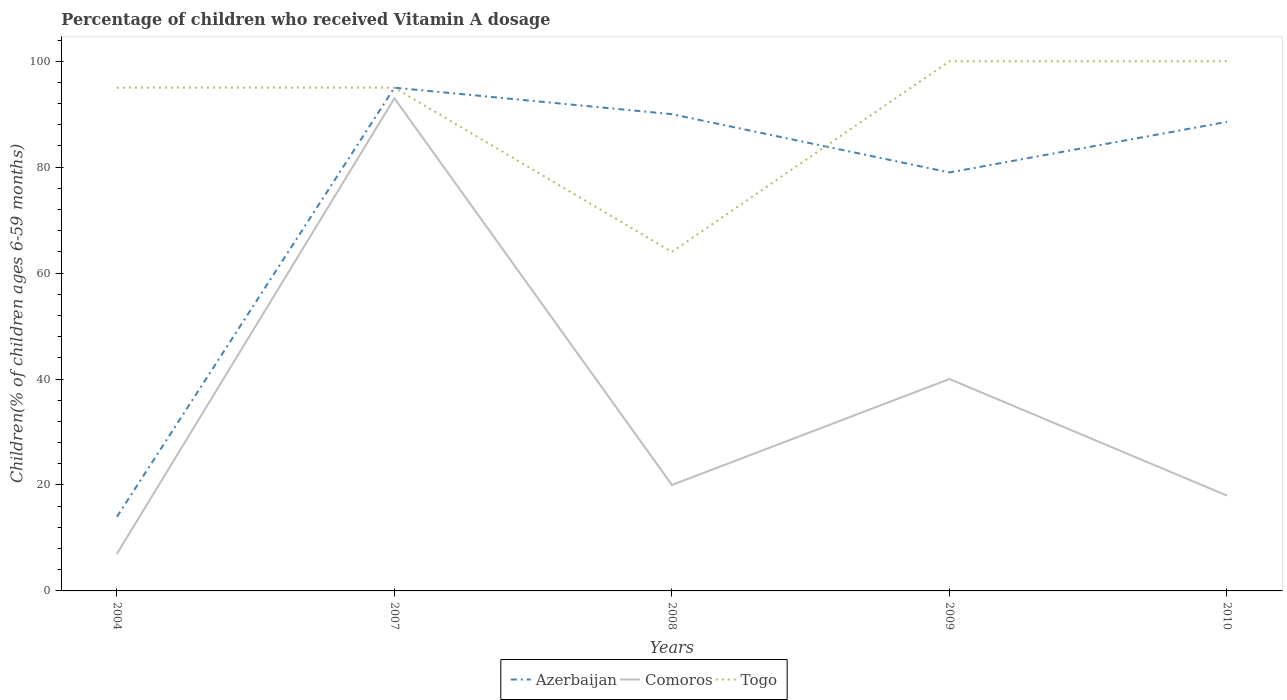How many different coloured lines are there?
Your answer should be very brief. 3. Across all years, what is the maximum percentage of children who received Vitamin A dosage in Togo?
Your answer should be compact. 64. Is the percentage of children who received Vitamin A dosage in Togo strictly greater than the percentage of children who received Vitamin A dosage in Comoros over the years?
Your answer should be very brief. No. How many lines are there?
Give a very brief answer. 3. What is the difference between two consecutive major ticks on the Y-axis?
Your answer should be very brief. 20. Are the values on the major ticks of Y-axis written in scientific E-notation?
Ensure brevity in your answer.  No. Does the graph contain any zero values?
Your response must be concise. No. Where does the legend appear in the graph?
Offer a terse response. Bottom center. What is the title of the graph?
Offer a terse response. Percentage of children who received Vitamin A dosage. Does "Turkey" appear as one of the legend labels in the graph?
Provide a succinct answer. No. What is the label or title of the X-axis?
Your answer should be very brief. Years. What is the label or title of the Y-axis?
Keep it short and to the point. Children(% of children ages 6-59 months). What is the Children(% of children ages 6-59 months) of Azerbaijan in 2004?
Your response must be concise. 14. What is the Children(% of children ages 6-59 months) of Comoros in 2004?
Offer a terse response. 7. What is the Children(% of children ages 6-59 months) of Togo in 2004?
Keep it short and to the point. 95. What is the Children(% of children ages 6-59 months) in Azerbaijan in 2007?
Provide a short and direct response. 95. What is the Children(% of children ages 6-59 months) of Comoros in 2007?
Provide a short and direct response. 93. What is the Children(% of children ages 6-59 months) in Comoros in 2008?
Your answer should be very brief. 20. What is the Children(% of children ages 6-59 months) of Azerbaijan in 2009?
Ensure brevity in your answer.  79. What is the Children(% of children ages 6-59 months) of Comoros in 2009?
Provide a succinct answer. 40. What is the Children(% of children ages 6-59 months) of Azerbaijan in 2010?
Your response must be concise. 88.55. What is the Children(% of children ages 6-59 months) of Togo in 2010?
Make the answer very short. 100. Across all years, what is the maximum Children(% of children ages 6-59 months) of Azerbaijan?
Provide a succinct answer. 95. Across all years, what is the maximum Children(% of children ages 6-59 months) of Comoros?
Make the answer very short. 93. Across all years, what is the maximum Children(% of children ages 6-59 months) of Togo?
Provide a short and direct response. 100. Across all years, what is the minimum Children(% of children ages 6-59 months) in Azerbaijan?
Keep it short and to the point. 14. Across all years, what is the minimum Children(% of children ages 6-59 months) in Togo?
Your answer should be very brief. 64. What is the total Children(% of children ages 6-59 months) of Azerbaijan in the graph?
Your answer should be very brief. 366.55. What is the total Children(% of children ages 6-59 months) in Comoros in the graph?
Give a very brief answer. 178. What is the total Children(% of children ages 6-59 months) in Togo in the graph?
Your response must be concise. 454. What is the difference between the Children(% of children ages 6-59 months) of Azerbaijan in 2004 and that in 2007?
Your answer should be very brief. -81. What is the difference between the Children(% of children ages 6-59 months) of Comoros in 2004 and that in 2007?
Your answer should be compact. -86. What is the difference between the Children(% of children ages 6-59 months) in Azerbaijan in 2004 and that in 2008?
Ensure brevity in your answer.  -76. What is the difference between the Children(% of children ages 6-59 months) in Comoros in 2004 and that in 2008?
Keep it short and to the point. -13. What is the difference between the Children(% of children ages 6-59 months) of Azerbaijan in 2004 and that in 2009?
Make the answer very short. -65. What is the difference between the Children(% of children ages 6-59 months) of Comoros in 2004 and that in 2009?
Provide a succinct answer. -33. What is the difference between the Children(% of children ages 6-59 months) in Azerbaijan in 2004 and that in 2010?
Ensure brevity in your answer.  -74.55. What is the difference between the Children(% of children ages 6-59 months) in Togo in 2004 and that in 2010?
Offer a terse response. -5. What is the difference between the Children(% of children ages 6-59 months) of Comoros in 2007 and that in 2008?
Your answer should be very brief. 73. What is the difference between the Children(% of children ages 6-59 months) in Azerbaijan in 2007 and that in 2009?
Give a very brief answer. 16. What is the difference between the Children(% of children ages 6-59 months) in Comoros in 2007 and that in 2009?
Your answer should be compact. 53. What is the difference between the Children(% of children ages 6-59 months) in Togo in 2007 and that in 2009?
Your answer should be very brief. -5. What is the difference between the Children(% of children ages 6-59 months) of Azerbaijan in 2007 and that in 2010?
Your response must be concise. 6.45. What is the difference between the Children(% of children ages 6-59 months) in Comoros in 2007 and that in 2010?
Provide a short and direct response. 75. What is the difference between the Children(% of children ages 6-59 months) of Togo in 2007 and that in 2010?
Your answer should be very brief. -5. What is the difference between the Children(% of children ages 6-59 months) of Togo in 2008 and that in 2009?
Provide a short and direct response. -36. What is the difference between the Children(% of children ages 6-59 months) in Azerbaijan in 2008 and that in 2010?
Keep it short and to the point. 1.45. What is the difference between the Children(% of children ages 6-59 months) of Comoros in 2008 and that in 2010?
Offer a terse response. 2. What is the difference between the Children(% of children ages 6-59 months) in Togo in 2008 and that in 2010?
Offer a terse response. -36. What is the difference between the Children(% of children ages 6-59 months) of Azerbaijan in 2009 and that in 2010?
Your answer should be compact. -9.55. What is the difference between the Children(% of children ages 6-59 months) in Comoros in 2009 and that in 2010?
Your response must be concise. 22. What is the difference between the Children(% of children ages 6-59 months) of Azerbaijan in 2004 and the Children(% of children ages 6-59 months) of Comoros in 2007?
Give a very brief answer. -79. What is the difference between the Children(% of children ages 6-59 months) in Azerbaijan in 2004 and the Children(% of children ages 6-59 months) in Togo in 2007?
Keep it short and to the point. -81. What is the difference between the Children(% of children ages 6-59 months) of Comoros in 2004 and the Children(% of children ages 6-59 months) of Togo in 2007?
Provide a succinct answer. -88. What is the difference between the Children(% of children ages 6-59 months) of Azerbaijan in 2004 and the Children(% of children ages 6-59 months) of Togo in 2008?
Your answer should be very brief. -50. What is the difference between the Children(% of children ages 6-59 months) in Comoros in 2004 and the Children(% of children ages 6-59 months) in Togo in 2008?
Offer a very short reply. -57. What is the difference between the Children(% of children ages 6-59 months) in Azerbaijan in 2004 and the Children(% of children ages 6-59 months) in Comoros in 2009?
Your answer should be compact. -26. What is the difference between the Children(% of children ages 6-59 months) of Azerbaijan in 2004 and the Children(% of children ages 6-59 months) of Togo in 2009?
Your response must be concise. -86. What is the difference between the Children(% of children ages 6-59 months) of Comoros in 2004 and the Children(% of children ages 6-59 months) of Togo in 2009?
Your answer should be compact. -93. What is the difference between the Children(% of children ages 6-59 months) of Azerbaijan in 2004 and the Children(% of children ages 6-59 months) of Togo in 2010?
Keep it short and to the point. -86. What is the difference between the Children(% of children ages 6-59 months) in Comoros in 2004 and the Children(% of children ages 6-59 months) in Togo in 2010?
Keep it short and to the point. -93. What is the difference between the Children(% of children ages 6-59 months) in Azerbaijan in 2007 and the Children(% of children ages 6-59 months) in Togo in 2008?
Your answer should be compact. 31. What is the difference between the Children(% of children ages 6-59 months) of Azerbaijan in 2007 and the Children(% of children ages 6-59 months) of Togo in 2009?
Offer a terse response. -5. What is the difference between the Children(% of children ages 6-59 months) of Comoros in 2007 and the Children(% of children ages 6-59 months) of Togo in 2009?
Your response must be concise. -7. What is the difference between the Children(% of children ages 6-59 months) in Azerbaijan in 2007 and the Children(% of children ages 6-59 months) in Togo in 2010?
Provide a short and direct response. -5. What is the difference between the Children(% of children ages 6-59 months) in Azerbaijan in 2008 and the Children(% of children ages 6-59 months) in Comoros in 2009?
Provide a succinct answer. 50. What is the difference between the Children(% of children ages 6-59 months) in Comoros in 2008 and the Children(% of children ages 6-59 months) in Togo in 2009?
Keep it short and to the point. -80. What is the difference between the Children(% of children ages 6-59 months) of Azerbaijan in 2008 and the Children(% of children ages 6-59 months) of Togo in 2010?
Your answer should be compact. -10. What is the difference between the Children(% of children ages 6-59 months) of Comoros in 2008 and the Children(% of children ages 6-59 months) of Togo in 2010?
Ensure brevity in your answer.  -80. What is the difference between the Children(% of children ages 6-59 months) in Azerbaijan in 2009 and the Children(% of children ages 6-59 months) in Comoros in 2010?
Your answer should be very brief. 61. What is the difference between the Children(% of children ages 6-59 months) in Comoros in 2009 and the Children(% of children ages 6-59 months) in Togo in 2010?
Make the answer very short. -60. What is the average Children(% of children ages 6-59 months) in Azerbaijan per year?
Your answer should be compact. 73.31. What is the average Children(% of children ages 6-59 months) in Comoros per year?
Provide a succinct answer. 35.6. What is the average Children(% of children ages 6-59 months) of Togo per year?
Your answer should be very brief. 90.8. In the year 2004, what is the difference between the Children(% of children ages 6-59 months) in Azerbaijan and Children(% of children ages 6-59 months) in Comoros?
Provide a succinct answer. 7. In the year 2004, what is the difference between the Children(% of children ages 6-59 months) of Azerbaijan and Children(% of children ages 6-59 months) of Togo?
Provide a short and direct response. -81. In the year 2004, what is the difference between the Children(% of children ages 6-59 months) of Comoros and Children(% of children ages 6-59 months) of Togo?
Provide a short and direct response. -88. In the year 2007, what is the difference between the Children(% of children ages 6-59 months) of Azerbaijan and Children(% of children ages 6-59 months) of Togo?
Your answer should be very brief. 0. In the year 2008, what is the difference between the Children(% of children ages 6-59 months) of Azerbaijan and Children(% of children ages 6-59 months) of Comoros?
Offer a terse response. 70. In the year 2008, what is the difference between the Children(% of children ages 6-59 months) of Azerbaijan and Children(% of children ages 6-59 months) of Togo?
Give a very brief answer. 26. In the year 2008, what is the difference between the Children(% of children ages 6-59 months) in Comoros and Children(% of children ages 6-59 months) in Togo?
Your answer should be compact. -44. In the year 2009, what is the difference between the Children(% of children ages 6-59 months) in Azerbaijan and Children(% of children ages 6-59 months) in Togo?
Keep it short and to the point. -21. In the year 2009, what is the difference between the Children(% of children ages 6-59 months) of Comoros and Children(% of children ages 6-59 months) of Togo?
Give a very brief answer. -60. In the year 2010, what is the difference between the Children(% of children ages 6-59 months) in Azerbaijan and Children(% of children ages 6-59 months) in Comoros?
Offer a terse response. 70.55. In the year 2010, what is the difference between the Children(% of children ages 6-59 months) in Azerbaijan and Children(% of children ages 6-59 months) in Togo?
Provide a short and direct response. -11.45. In the year 2010, what is the difference between the Children(% of children ages 6-59 months) of Comoros and Children(% of children ages 6-59 months) of Togo?
Give a very brief answer. -82. What is the ratio of the Children(% of children ages 6-59 months) of Azerbaijan in 2004 to that in 2007?
Offer a terse response. 0.15. What is the ratio of the Children(% of children ages 6-59 months) in Comoros in 2004 to that in 2007?
Make the answer very short. 0.08. What is the ratio of the Children(% of children ages 6-59 months) in Azerbaijan in 2004 to that in 2008?
Make the answer very short. 0.16. What is the ratio of the Children(% of children ages 6-59 months) in Comoros in 2004 to that in 2008?
Offer a very short reply. 0.35. What is the ratio of the Children(% of children ages 6-59 months) of Togo in 2004 to that in 2008?
Your response must be concise. 1.48. What is the ratio of the Children(% of children ages 6-59 months) in Azerbaijan in 2004 to that in 2009?
Provide a short and direct response. 0.18. What is the ratio of the Children(% of children ages 6-59 months) of Comoros in 2004 to that in 2009?
Offer a very short reply. 0.17. What is the ratio of the Children(% of children ages 6-59 months) in Togo in 2004 to that in 2009?
Your answer should be very brief. 0.95. What is the ratio of the Children(% of children ages 6-59 months) of Azerbaijan in 2004 to that in 2010?
Make the answer very short. 0.16. What is the ratio of the Children(% of children ages 6-59 months) of Comoros in 2004 to that in 2010?
Make the answer very short. 0.39. What is the ratio of the Children(% of children ages 6-59 months) of Togo in 2004 to that in 2010?
Your response must be concise. 0.95. What is the ratio of the Children(% of children ages 6-59 months) in Azerbaijan in 2007 to that in 2008?
Ensure brevity in your answer.  1.06. What is the ratio of the Children(% of children ages 6-59 months) in Comoros in 2007 to that in 2008?
Offer a terse response. 4.65. What is the ratio of the Children(% of children ages 6-59 months) of Togo in 2007 to that in 2008?
Offer a terse response. 1.48. What is the ratio of the Children(% of children ages 6-59 months) in Azerbaijan in 2007 to that in 2009?
Offer a terse response. 1.2. What is the ratio of the Children(% of children ages 6-59 months) in Comoros in 2007 to that in 2009?
Offer a very short reply. 2.33. What is the ratio of the Children(% of children ages 6-59 months) of Togo in 2007 to that in 2009?
Ensure brevity in your answer.  0.95. What is the ratio of the Children(% of children ages 6-59 months) of Azerbaijan in 2007 to that in 2010?
Keep it short and to the point. 1.07. What is the ratio of the Children(% of children ages 6-59 months) of Comoros in 2007 to that in 2010?
Offer a very short reply. 5.17. What is the ratio of the Children(% of children ages 6-59 months) in Azerbaijan in 2008 to that in 2009?
Your answer should be compact. 1.14. What is the ratio of the Children(% of children ages 6-59 months) of Togo in 2008 to that in 2009?
Your answer should be compact. 0.64. What is the ratio of the Children(% of children ages 6-59 months) in Azerbaijan in 2008 to that in 2010?
Ensure brevity in your answer.  1.02. What is the ratio of the Children(% of children ages 6-59 months) of Togo in 2008 to that in 2010?
Provide a short and direct response. 0.64. What is the ratio of the Children(% of children ages 6-59 months) in Azerbaijan in 2009 to that in 2010?
Make the answer very short. 0.89. What is the ratio of the Children(% of children ages 6-59 months) of Comoros in 2009 to that in 2010?
Your response must be concise. 2.22. What is the ratio of the Children(% of children ages 6-59 months) in Togo in 2009 to that in 2010?
Offer a terse response. 1. What is the difference between the highest and the second highest Children(% of children ages 6-59 months) in Togo?
Keep it short and to the point. 0. What is the difference between the highest and the lowest Children(% of children ages 6-59 months) in Togo?
Your answer should be compact. 36. 